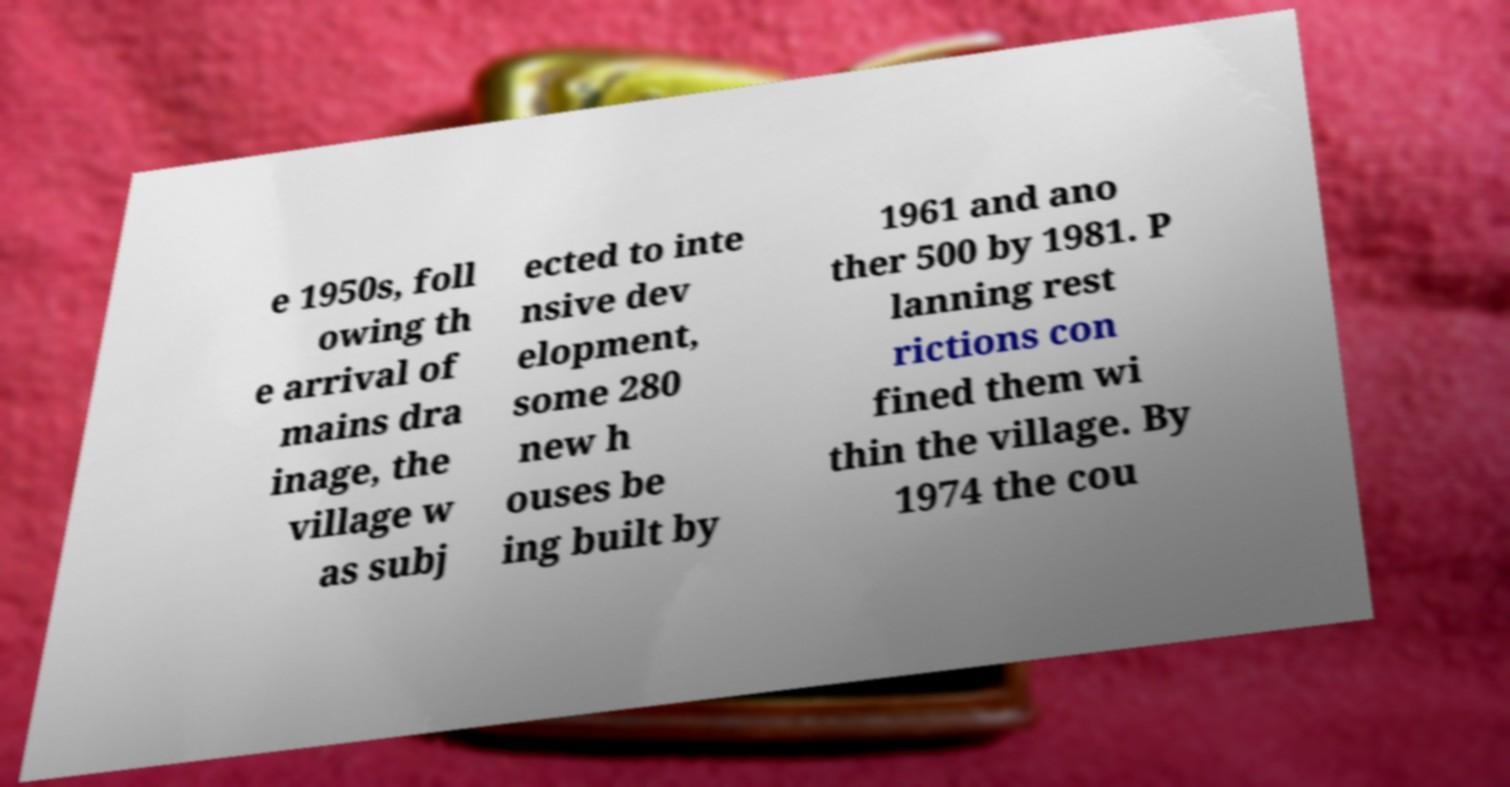Please identify and transcribe the text found in this image. e 1950s, foll owing th e arrival of mains dra inage, the village w as subj ected to inte nsive dev elopment, some 280 new h ouses be ing built by 1961 and ano ther 500 by 1981. P lanning rest rictions con fined them wi thin the village. By 1974 the cou 